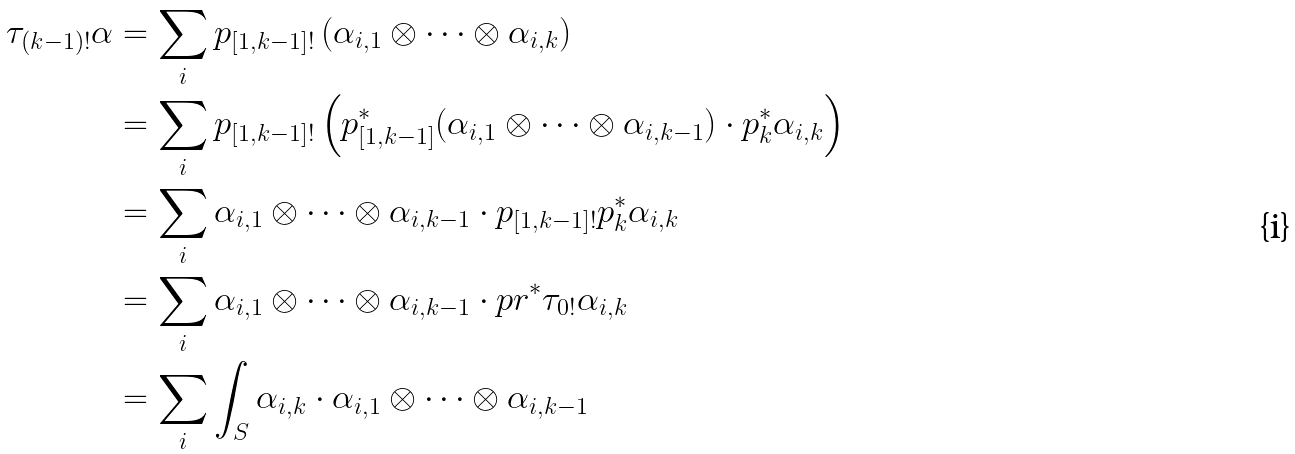<formula> <loc_0><loc_0><loc_500><loc_500>\tau _ { ( k - 1 ) ! } \alpha & = \sum _ { i } p _ { [ 1 , k - 1 ] ! } \left ( \alpha _ { i , 1 } \otimes \cdots \otimes \alpha _ { i , k } \right ) \\ & = \sum _ { i } p _ { [ 1 , k - 1 ] ! } \left ( p _ { [ 1 , k - 1 ] } ^ { * } ( \alpha _ { i , 1 } \otimes \cdots \otimes \alpha _ { i , k - 1 } ) \cdot p _ { k } ^ { * } \alpha _ { i , k } \right ) \\ & = \sum _ { i } \alpha _ { i , 1 } \otimes \cdots \otimes \alpha _ { i , k - 1 } \cdot p _ { [ 1 , k - 1 ] ! } p _ { k } ^ { * } \alpha _ { i , k } \\ & = \sum _ { i } \alpha _ { i , 1 } \otimes \cdots \otimes \alpha _ { i , k - 1 } \cdot p r ^ { * } \tau _ { 0 ! } \alpha _ { i , k } \\ & = \sum _ { i } \int _ { S } \alpha _ { i , k } \cdot \alpha _ { i , 1 } \otimes \cdots \otimes \alpha _ { i , k - 1 }</formula> 